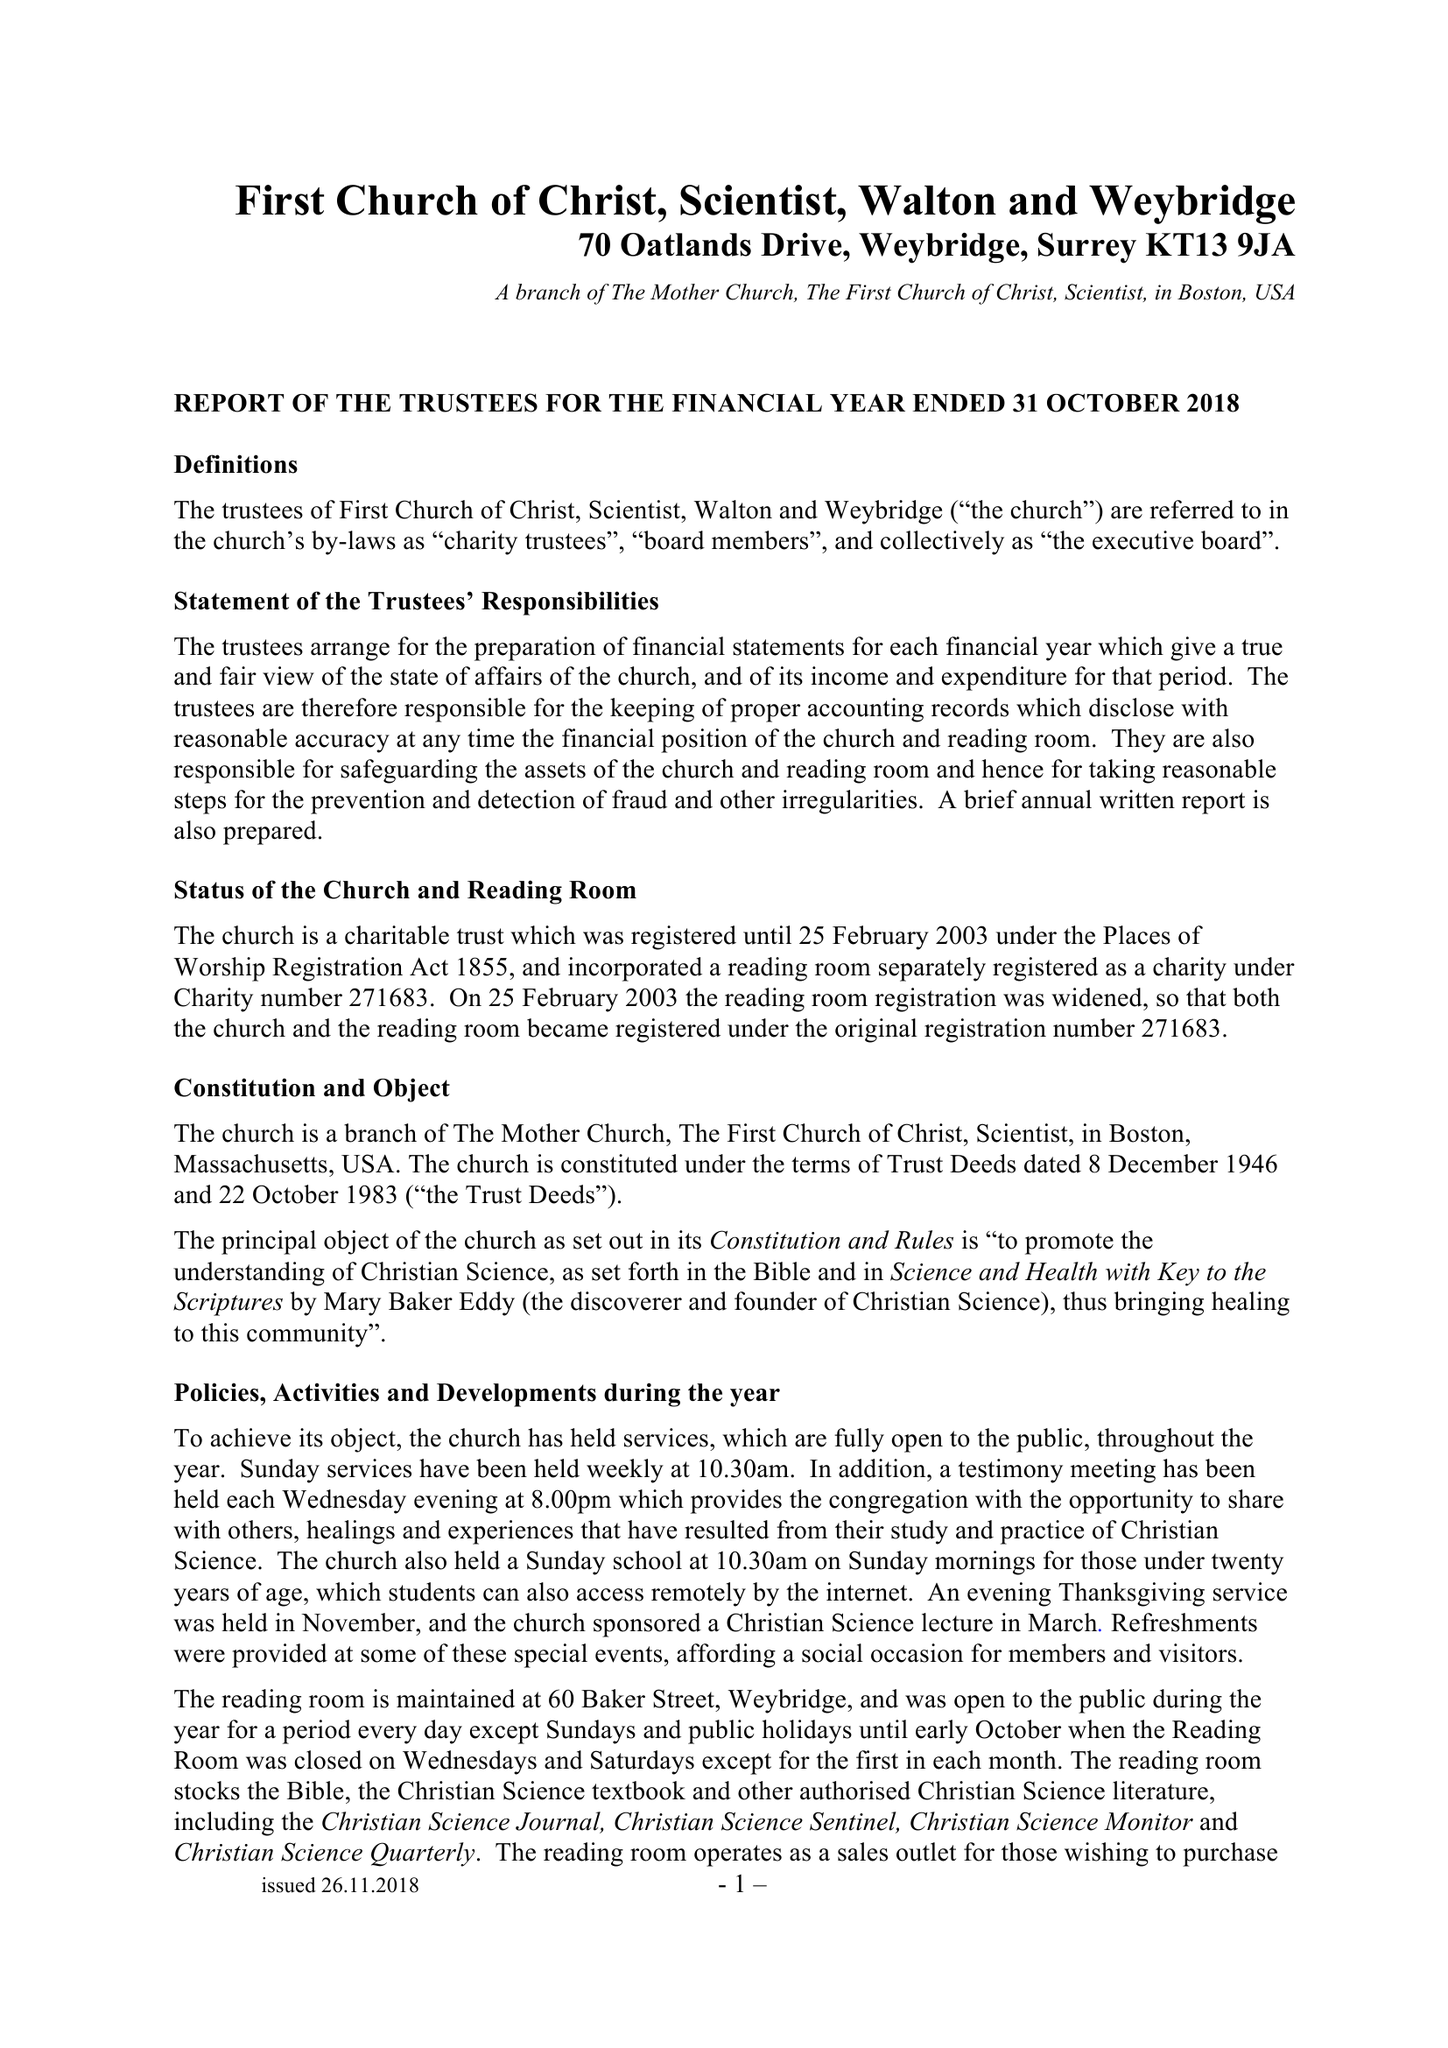What is the value for the address__postcode?
Answer the question using a single word or phrase. KT13 9JA 